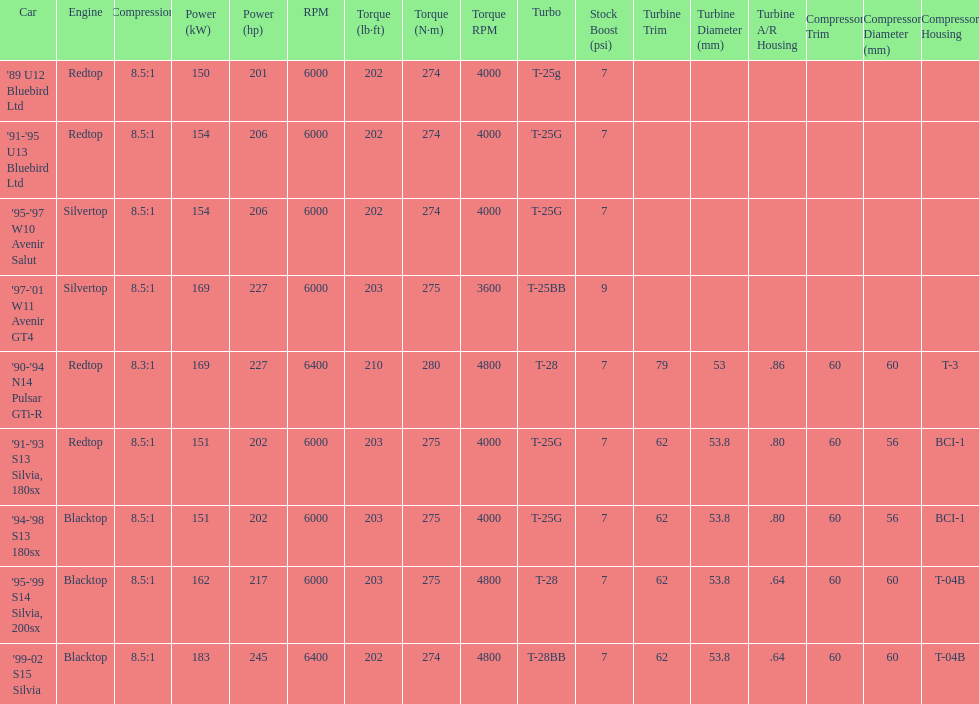Which cars featured blacktop engines? '94-'98 S13 180sx, '95-'99 S14 Silvia, 200sx, '99-02 S15 Silvia. Which of these had t-04b compressor housings? '95-'99 S14 Silvia, 200sx, '99-02 S15 Silvia. Which one of these has the highest horsepower? '99-02 S15 Silvia. 